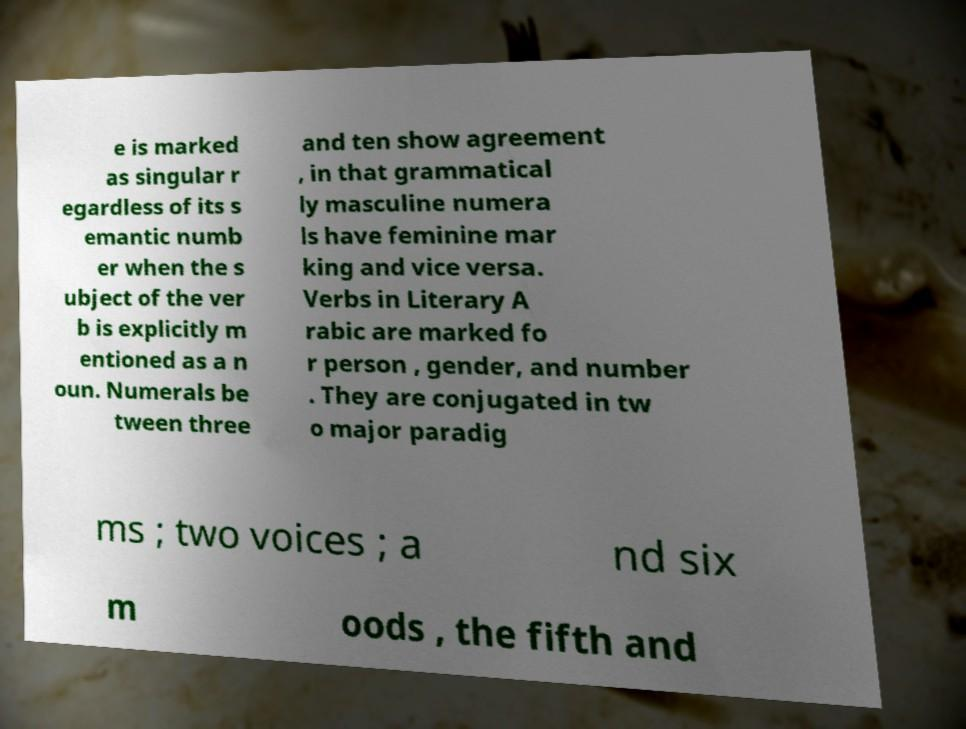What messages or text are displayed in this image? I need them in a readable, typed format. e is marked as singular r egardless of its s emantic numb er when the s ubject of the ver b is explicitly m entioned as a n oun. Numerals be tween three and ten show agreement , in that grammatical ly masculine numera ls have feminine mar king and vice versa. Verbs in Literary A rabic are marked fo r person , gender, and number . They are conjugated in tw o major paradig ms ; two voices ; a nd six m oods , the fifth and 